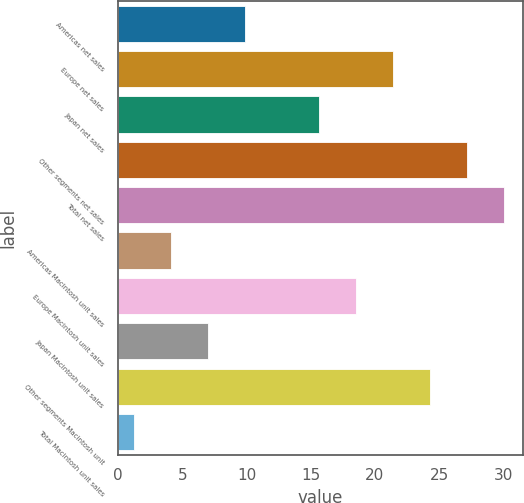<chart> <loc_0><loc_0><loc_500><loc_500><bar_chart><fcel>Americas net sales<fcel>Europe net sales<fcel>Japan net sales<fcel>Other segments net sales<fcel>Total net sales<fcel>Americas Macintosh unit sales<fcel>Europe Macintosh unit sales<fcel>Japan Macintosh unit sales<fcel>Other segments Macintosh unit<fcel>Total Macintosh unit sales<nl><fcel>9.88<fcel>21.4<fcel>15.64<fcel>27.16<fcel>30.04<fcel>4.12<fcel>18.52<fcel>7<fcel>24.28<fcel>1.24<nl></chart> 